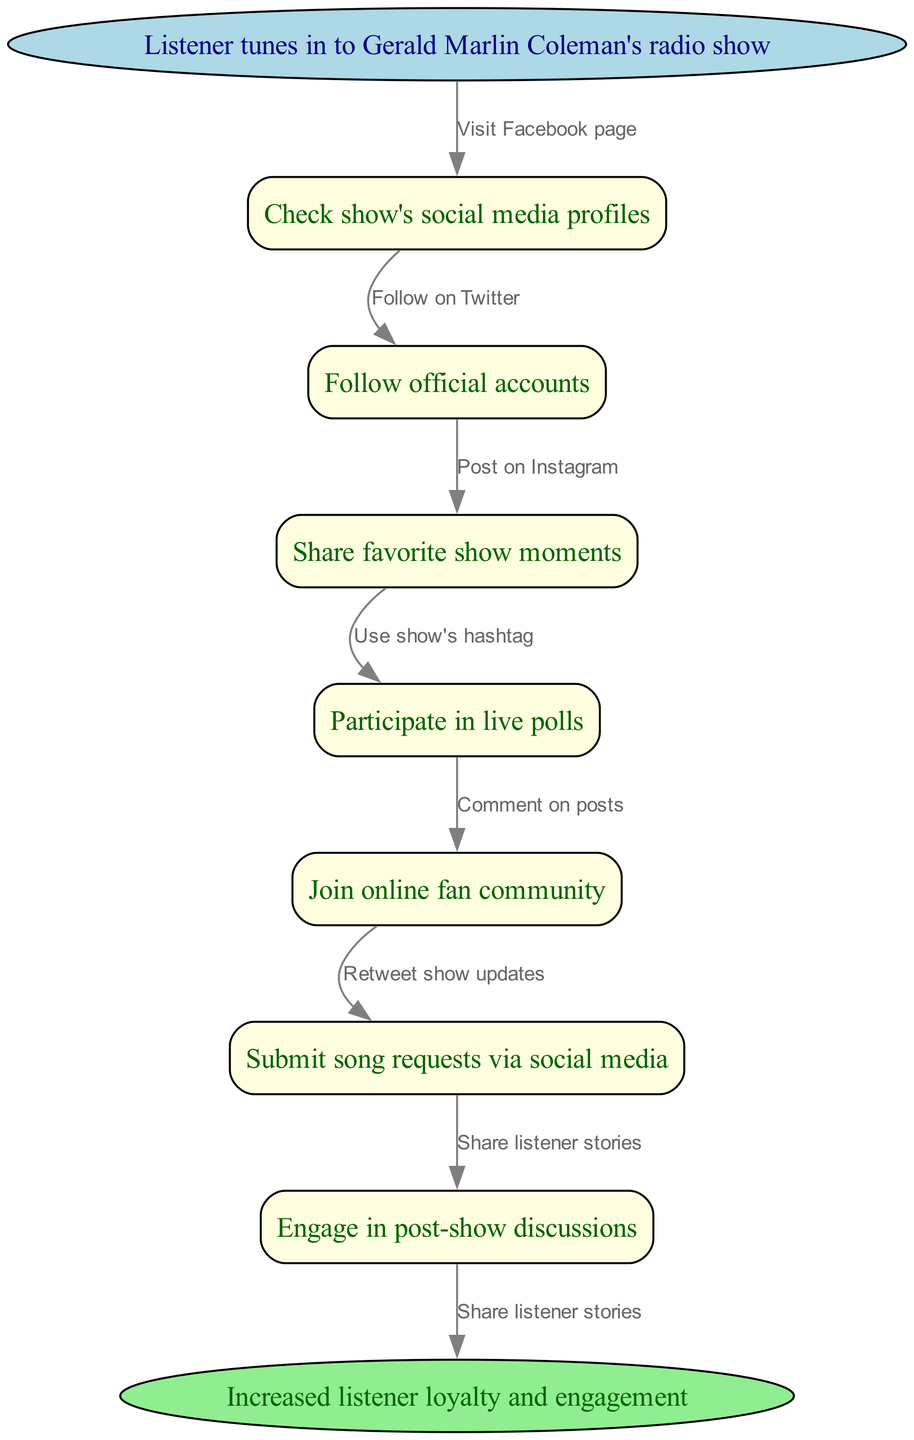What is the starting point of the listener engagement process? The starting point is the node labeled "Listener tunes in to Gerald Marlin Coleman's radio show." This can be straightforwardly identified as the first node in the flowchart, indicating where the process begins.
Answer: Listener tunes in to Gerald Marlin Coleman's radio show How many intermediate nodes are present in the diagram? There are 7 intermediate nodes listed in the diagram, detailing various engagement actions listeners can take. The count can be verified by directly reviewing the list of nodes provided.
Answer: 7 What is the last action before increased listener loyalty and engagement? The last action before reaching the end node is "Engage in post-show discussions." This can be traced from the final node in the sequence leading to the end node, confirming it as the last step.
Answer: Engage in post-show discussions Which social media action comes after checking the show's profiles? After checking the show's social media profiles, the next action is "Follow official accounts." This is derived from the sequential flow in the diagram where one action leads to the next.
Answer: Follow official accounts How many edges are present in the flowchart? The flowchart contains 8 edges, which represent the directed connections between the nodes, indicating the flow from one action to another throughout the process. This can be confirmed by counting the connections shown in the diagram.
Answer: 8 What node corresponds to submitting song requests? The node corresponding to submitting song requests is "Submit song requests via social media." By locating this specific action in the intermediate nodes, we can directly identify it.
Answer: Submit song requests via social media What is the purpose of the engagement process depicted in the flowchart? The purpose of the engagement process is to achieve "Increased listener loyalty and engagement." This conclusion can be drawn from looking at the end node, which encapsulates the overall goal of the entire process.
Answer: Increased listener loyalty and engagement What is the first action that a listener takes after tuning into the show? The first action a listener takes after tuning in is "Check show's social media profiles." This is observed as the first arrow leading from the start node to the next action in the flowchart.
Answer: Check show's social media profiles What type of node is used for the start and end points in the diagram? The start and end points are represented as ellipse-shaped nodes. This is evident from the shape attributes defined for those nodes in the diagram.
Answer: ellipse-shaped 